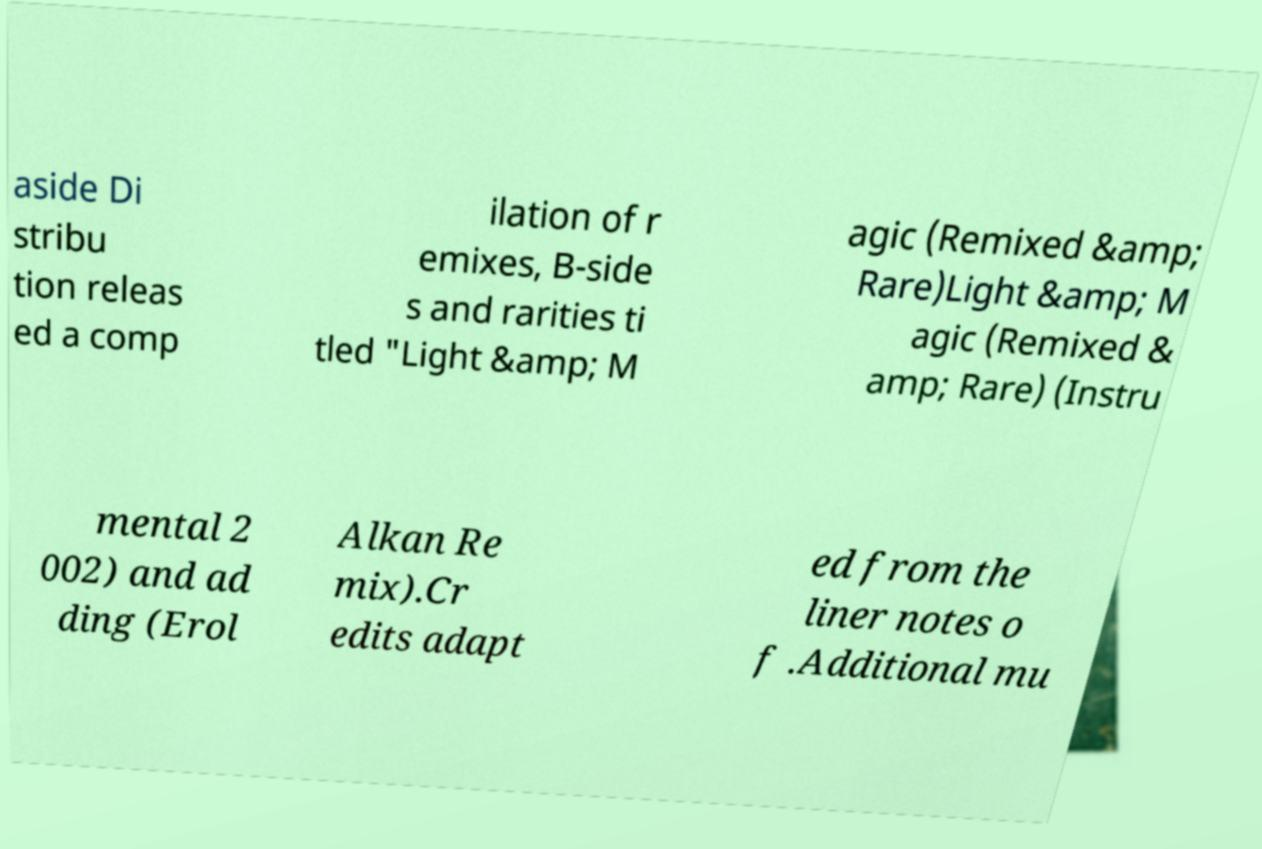What messages or text are displayed in this image? I need them in a readable, typed format. aside Di stribu tion releas ed a comp ilation of r emixes, B-side s and rarities ti tled "Light &amp; M agic (Remixed &amp; Rare)Light &amp; M agic (Remixed & amp; Rare) (Instru mental 2 002) and ad ding (Erol Alkan Re mix).Cr edits adapt ed from the liner notes o f .Additional mu 